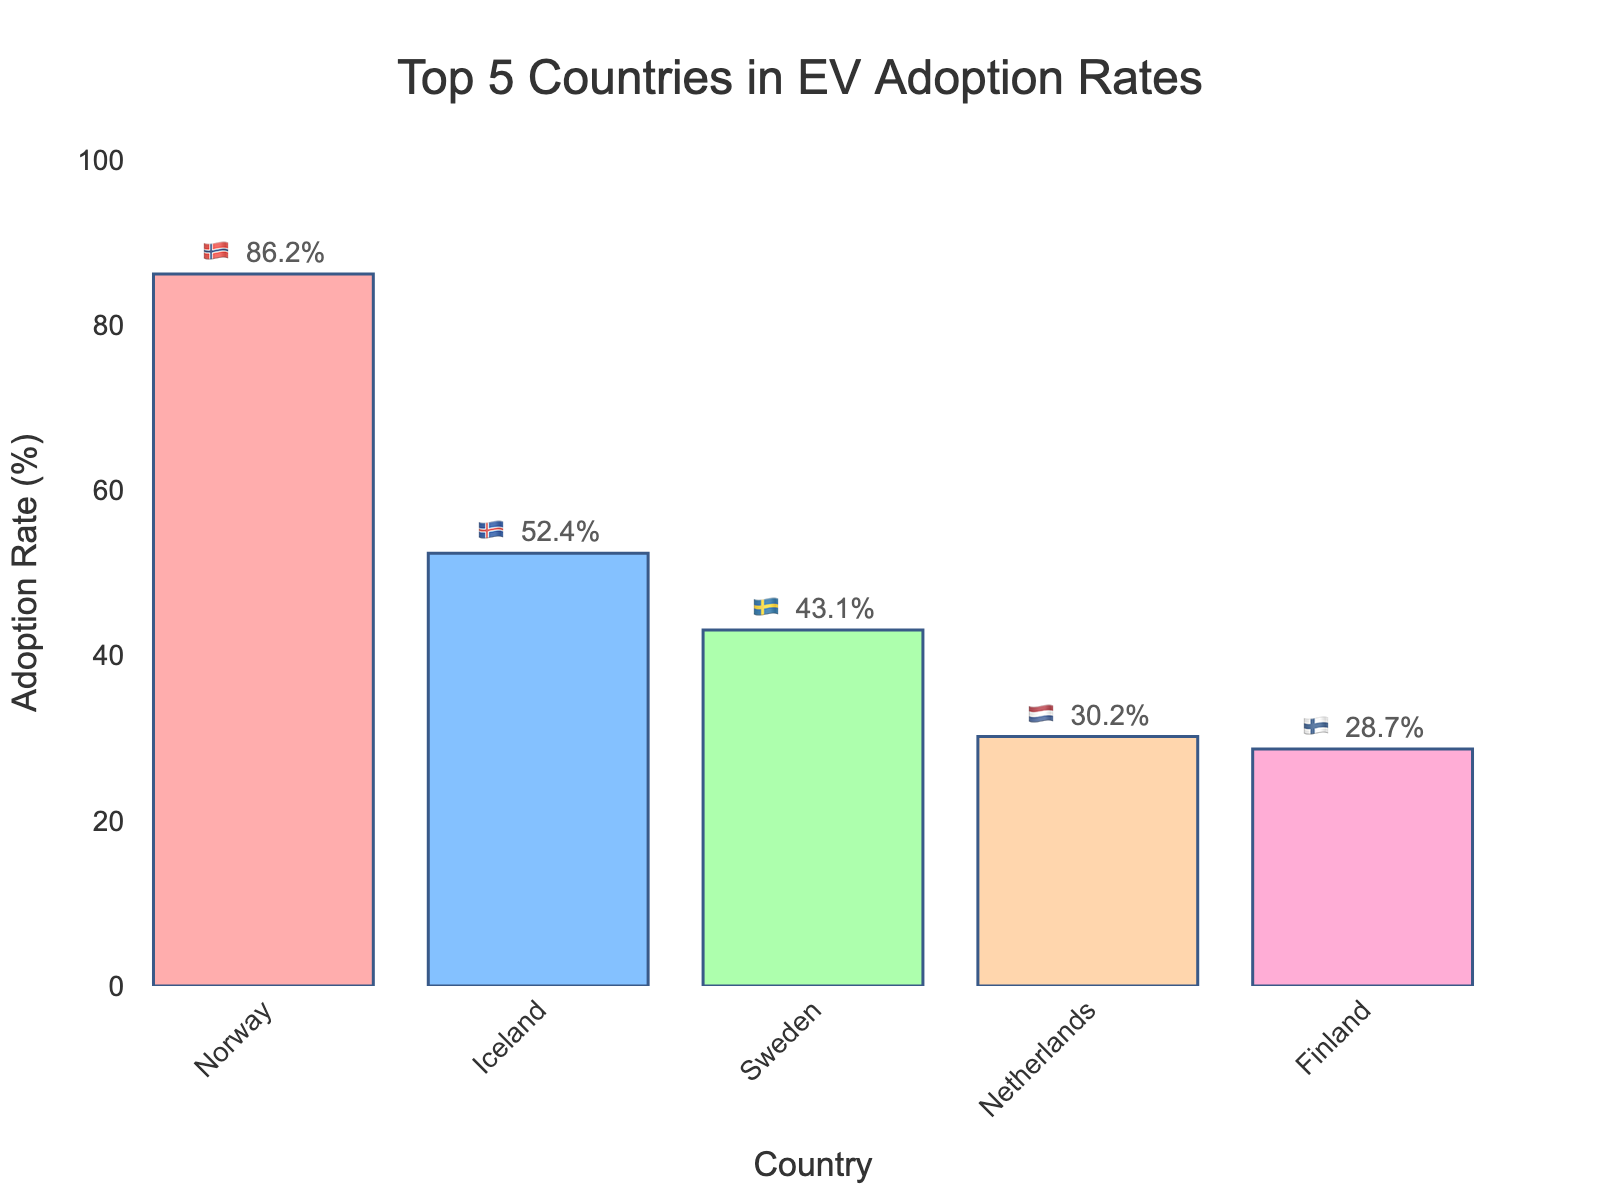Which country has the highest EV adoption rate? Looking at the top of the bar chart, Norway has the highest bar.
Answer: Norway 🇳🇴 What is the title of the chart? The title is displayed prominently at the top of the chart.
Answer: Top 5 Countries in EV Adoption Rates Which country has the lowest EV adoption rate among the top 5? The shortest bar corresponds to Finland.
Answer: Finland 🇫🇮 How much higher is Norway's EV adoption rate compared to Finland's? Norway's rate is 86.2%, and Finland's rate is 28.7%. The difference is 86.2 - 28.7 = 57.5%.
Answer: 57.5% What is the average EV adoption rate of these top 5 countries? Adding rates and dividing by 5: (86.2 + 52.4 + 43.1 + 30.2 + 28.7) / 5 = 48.12%.
Answer: 48.12% Which two countries have the closest EV adoption rates, and what are those rates? Iceland and Sweden have rates of 52.4% and 43.1%, which are closest to each other compared to other pairs.
Answer: Iceland 🇮🇸 (52.4%) and Sweden 🇸🇪 (43.1%) Are there any countries with an EV adoption rate above 50%? If so, which ones? By looking at the bars, Norway and Iceland have rates above 50%.
Answer: Norway 🇳🇴 and Iceland 🇮🇸 How does Sweden's EV adoption rate compare to the median adoption rate of these top 5 countries? Sorting rates: [28.7, 30.2, 43.1, 52.4, 86.2], the median is 43.1% (Sweden’s rate). They are equal.
Answer: Same as the median Which country is second in EV adoption rate? The second highest bar after Norway is Iceland.
Answer: Iceland 🇮🇸 